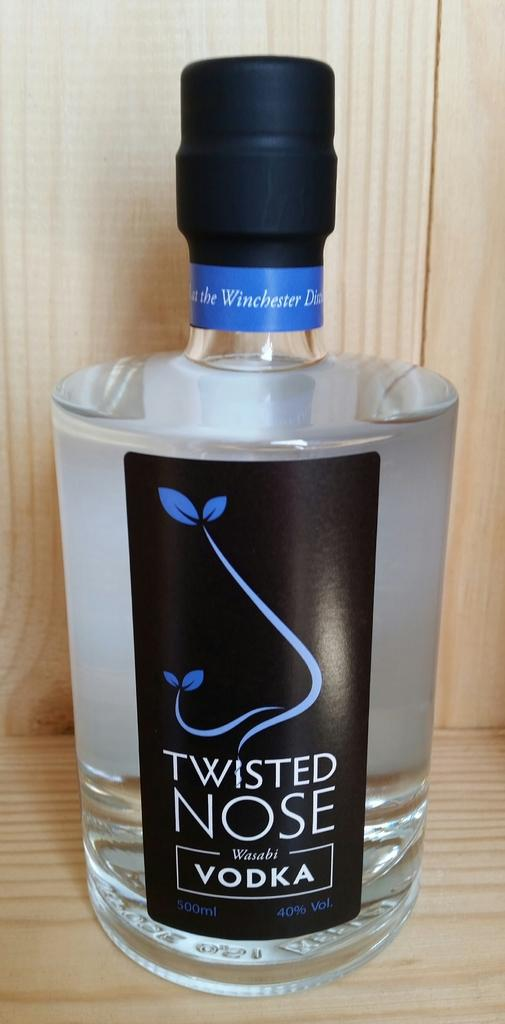<image>
Create a compact narrative representing the image presented. twisted nose vodka has a fancy nose for the label 